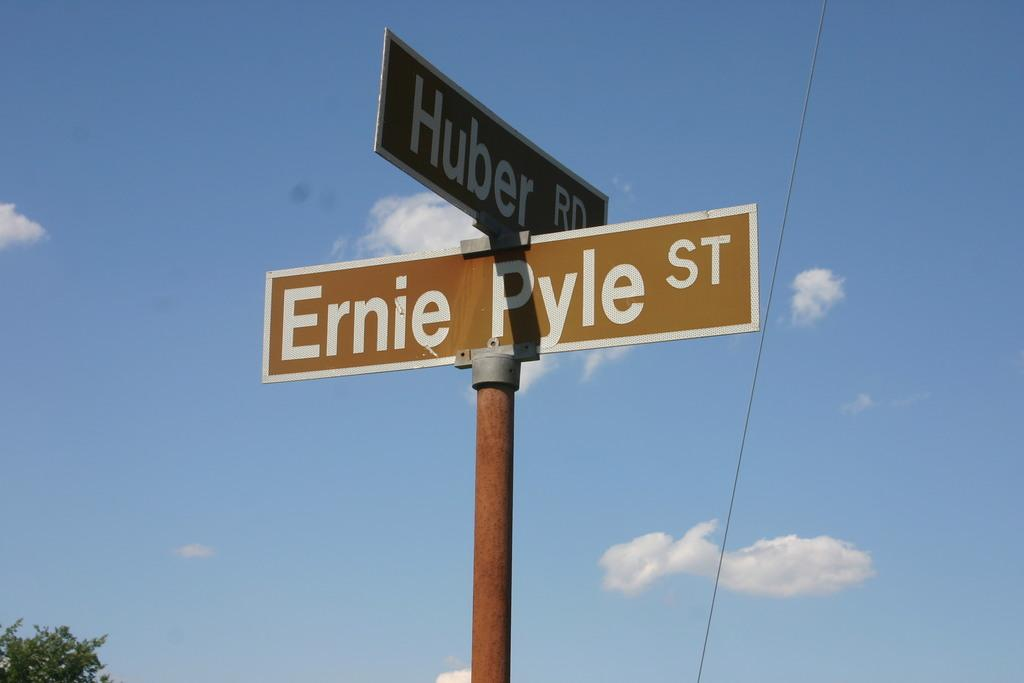<image>
Relay a brief, clear account of the picture shown. the word Ernie Pyle on the front of it 